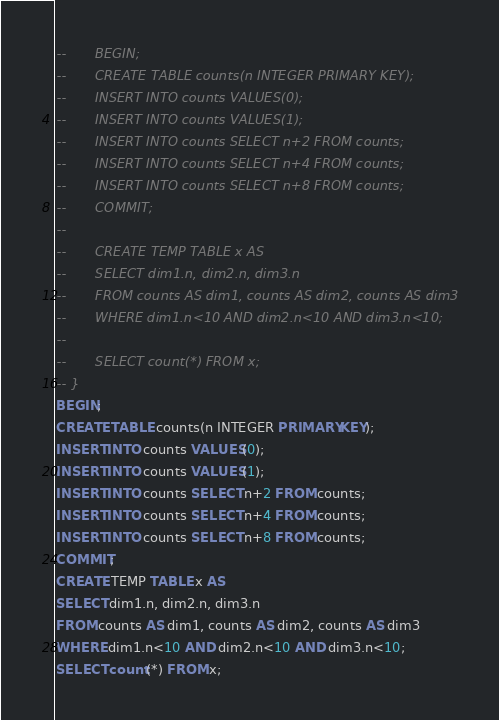<code> <loc_0><loc_0><loc_500><loc_500><_SQL_>--       BEGIN;
--       CREATE TABLE counts(n INTEGER PRIMARY KEY);
--       INSERT INTO counts VALUES(0);
--       INSERT INTO counts VALUES(1);
--       INSERT INTO counts SELECT n+2 FROM counts;
--       INSERT INTO counts SELECT n+4 FROM counts;
--       INSERT INTO counts SELECT n+8 FROM counts;
--       COMMIT;
--   
--       CREATE TEMP TABLE x AS
--       SELECT dim1.n, dim2.n, dim3.n
--       FROM counts AS dim1, counts AS dim2, counts AS dim3
--       WHERE dim1.n<10 AND dim2.n<10 AND dim3.n<10;
--   
--       SELECT count(*) FROM x;
-- }
BEGIN;
CREATE TABLE counts(n INTEGER PRIMARY KEY);
INSERT INTO counts VALUES(0);
INSERT INTO counts VALUES(1);
INSERT INTO counts SELECT n+2 FROM counts;
INSERT INTO counts SELECT n+4 FROM counts;
INSERT INTO counts SELECT n+8 FROM counts;
COMMIT;
CREATE TEMP TABLE x AS
SELECT dim1.n, dim2.n, dim3.n
FROM counts AS dim1, counts AS dim2, counts AS dim3
WHERE dim1.n<10 AND dim2.n<10 AND dim3.n<10;
SELECT count(*) FROM x;</code> 